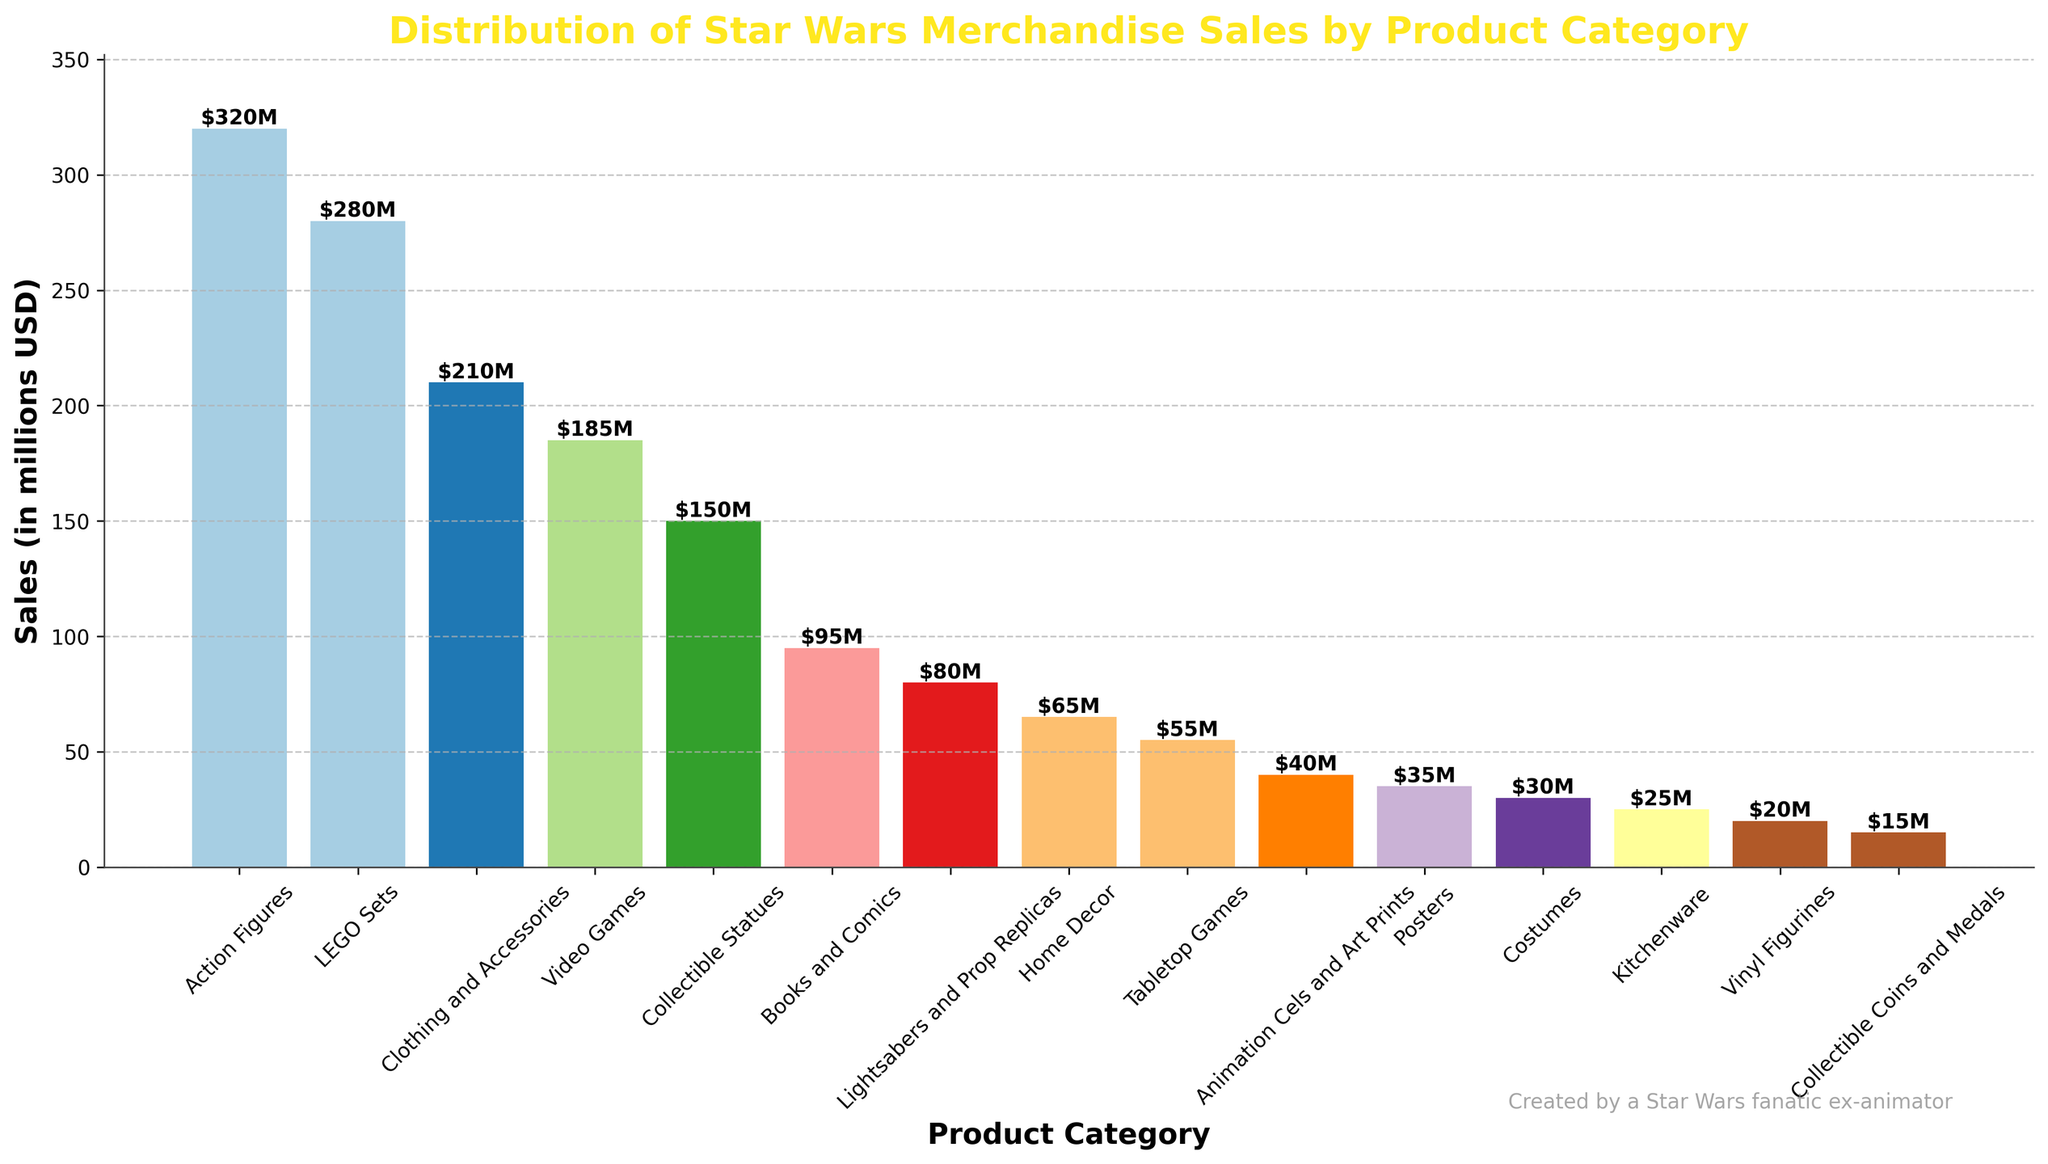Which product category has the highest sales? Identify the tallest bar in the chart, which corresponds to the category with the highest sales. This is the 'Action Figures' category.
Answer: Action Figures How much more are the sales of LEGO Sets than Collectible Statues? Find the sales of 'LEGO Sets' (280 million USD) and 'Collectible Statues' (150 million USD). Subtract the smaller number from the larger number: 280 - 150 = 130 million USD.
Answer: 130 million USD What is the total sales of Video Games and Books and Comics combined? Add the sales of 'Video Games' (185 million USD) to 'Books and Comics' (95 million USD): 185 + 95 = 280 million USD.
Answer: 280 million USD Which category has the lowest sales? Identify the shortest bar in the chart, which corresponds to the category with the lowest sales. This is the 'Collectible Coins and Medals' category.
Answer: Collectible Coins and Medals Are the sales of Lightsabers and Prop Replicas greater than Kitchenware? Compare the height of the bars representing 'Lightsabers and Prop Replicas' (80 million USD) and 'Kitchenware' (25 million USD). The bar for 'Lightsabers and Prop Replicas' is taller.
Answer: Yes What's the difference in sales between Home Decor and Posters? Find the sales of 'Home Decor' (65 million USD) and 'Posters' (35 million USD). Subtract the smaller number from the larger number: 65 - 35 = 30 million USD.
Answer: 30 million USD Which categories have sales less than 50 million USD? Identify the bars that are below the 50 million USD mark on the y-axis. These categories are 'Kitchenware' (25 million USD), 'Vinyl Figurines' (20 million USD), 'Collectible Coins and Medals' (15 million USD), and 'Costumes' (30 million USD).
Answer: Kitchenware, Vinyl Figurines, Collectible Coins and Medals, Costumes What percentage of the total sales is made up by Costumes? Calculate the total sales across all categories. Sum = 320 + 280 + 210 + 185 + 150 + 95 + 80 + 65 + 55 + 40 + 35 + 30 + 25 + 20 + 15 = 1605 million USD. Now, find the sales of 'Costumes' (30 million USD) and divide by the total sales, then multiply by 100: (30 / 1605) * 100 ≈ 1.87%.
Answer: 1.87% Which product categories have more than the average sales of all categories? First, calculate the average sales: Total sales = 1605 million USD, Number of categories = 15, Average = 1605 / 15 ≈ 107 million USD. Then identify categories with sales greater than 107 million USD. These categories are 'Action Figures' (320 million USD), 'LEGO Sets' (280 million USD), 'Clothing and Accessories' (210 million USD), and 'Video Games' (185 million USD).
Answer: Action Figures, LEGO Sets, Clothing and Accessories, Video Games 